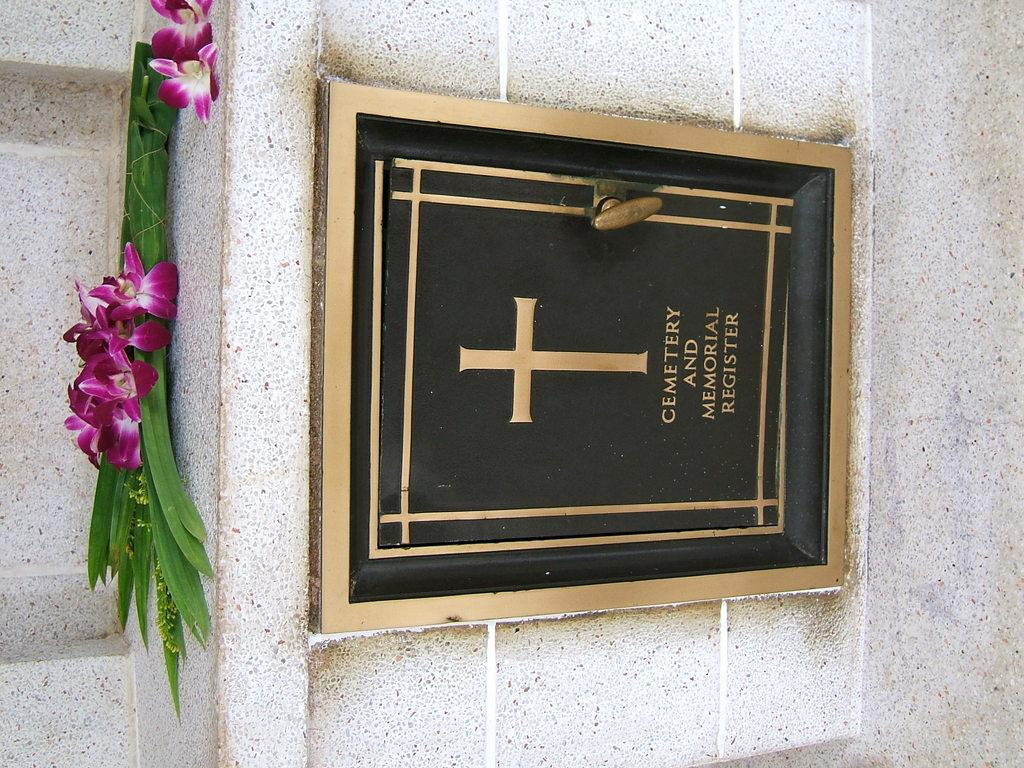Provide a one-sentence caption for the provided image. Sign that says "Cemetary and Memorial Register' under a flowe.r. 